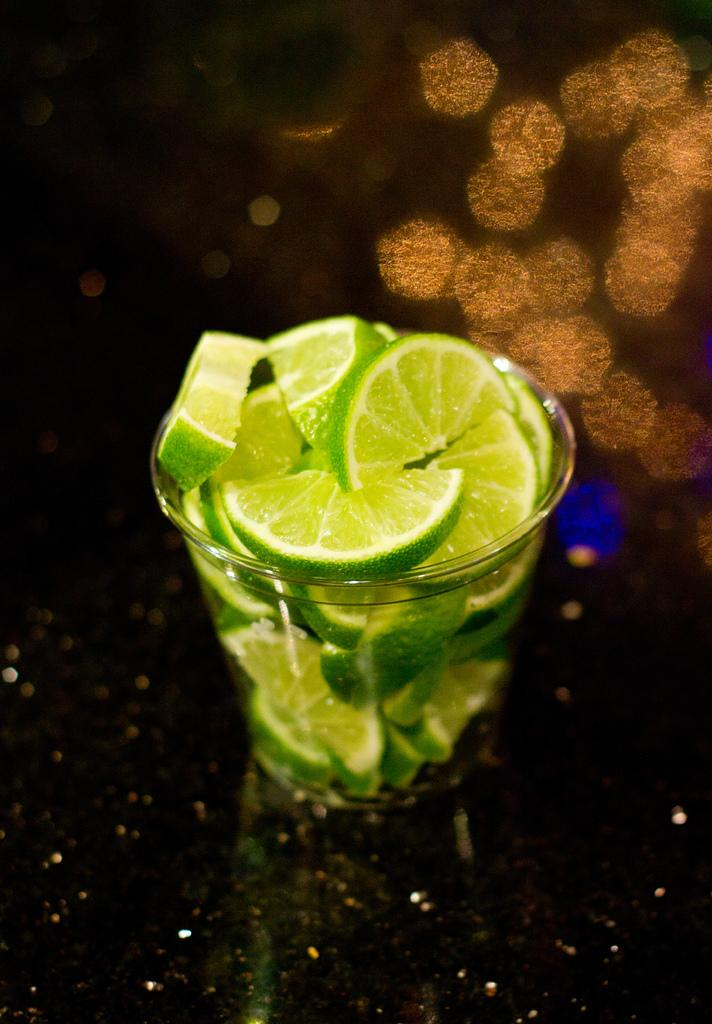What type of furniture is present in the image? There is a table in the image. What is the color of the table? The table is black in color. What object is placed on the table? There is a glass on the table. What is inside the glass? The glass is full of lemon slices. What type of building can be seen in the background of the image? There is no building present in the image; it only features a table, a black table, a glass, and lemon slices. 